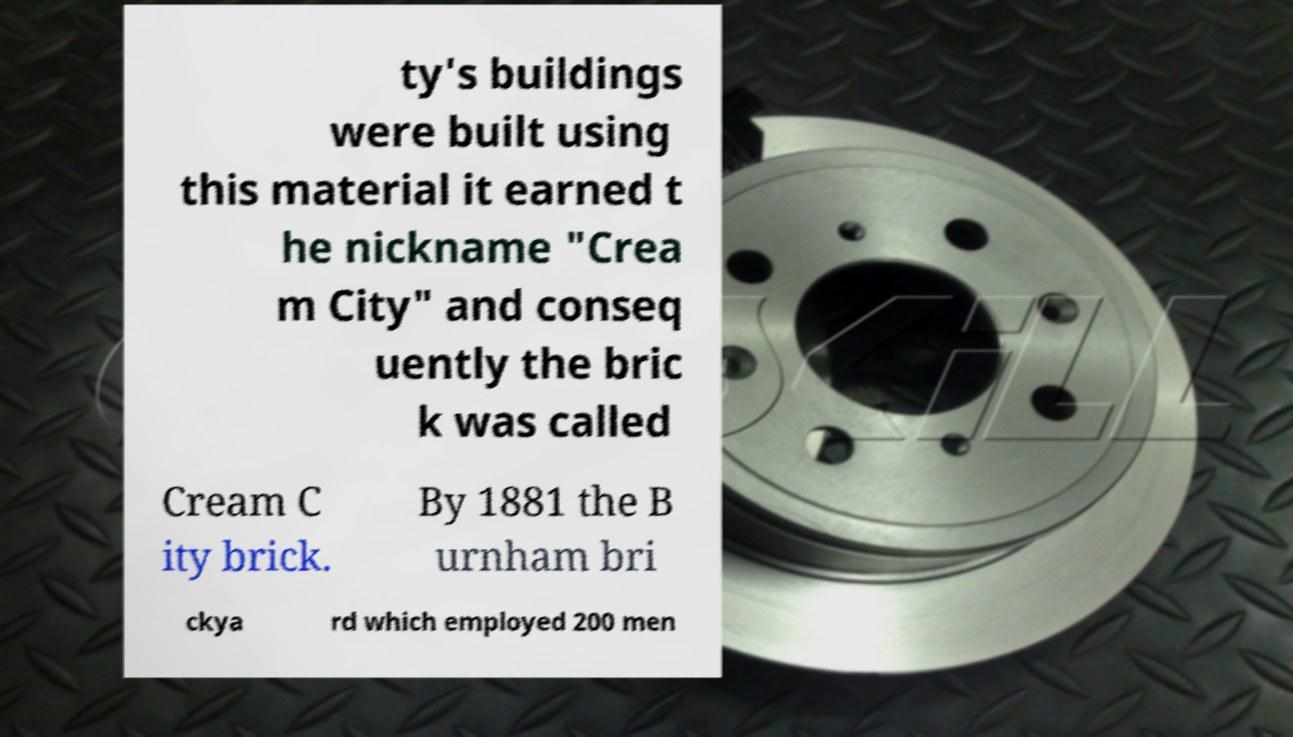Please read and relay the text visible in this image. What does it say? ty's buildings were built using this material it earned t he nickname "Crea m City" and conseq uently the bric k was called Cream C ity brick. By 1881 the B urnham bri ckya rd which employed 200 men 